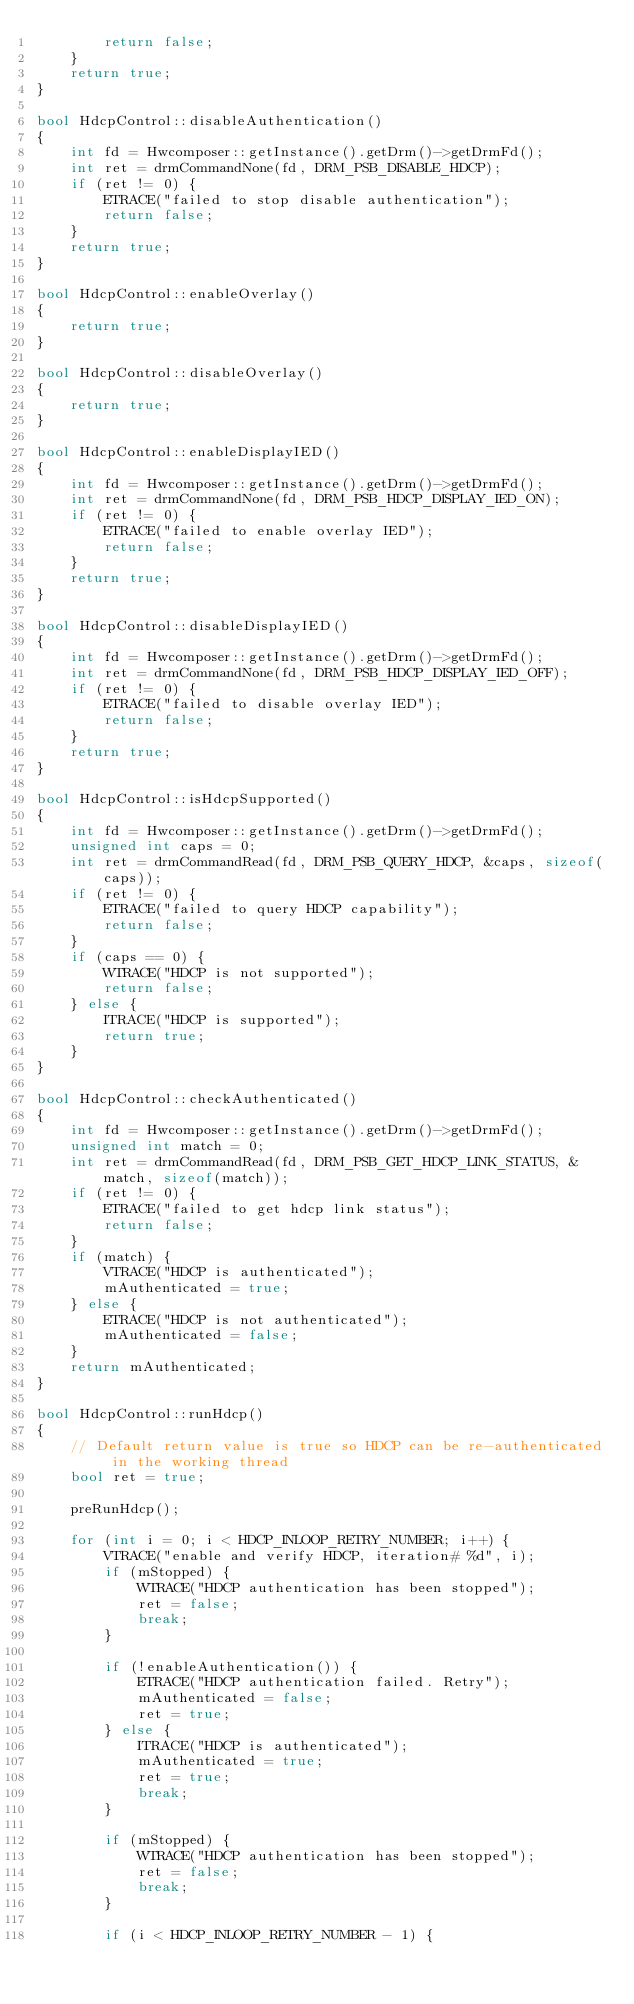Convert code to text. <code><loc_0><loc_0><loc_500><loc_500><_C++_>        return false;
    }
    return true;
}

bool HdcpControl::disableAuthentication()
{
    int fd = Hwcomposer::getInstance().getDrm()->getDrmFd();
    int ret = drmCommandNone(fd, DRM_PSB_DISABLE_HDCP);
    if (ret != 0) {
        ETRACE("failed to stop disable authentication");
        return false;
    }
    return true;
}

bool HdcpControl::enableOverlay()
{
    return true;
}

bool HdcpControl::disableOverlay()
{
    return true;
}

bool HdcpControl::enableDisplayIED()
{
    int fd = Hwcomposer::getInstance().getDrm()->getDrmFd();
    int ret = drmCommandNone(fd, DRM_PSB_HDCP_DISPLAY_IED_ON);
    if (ret != 0) {
        ETRACE("failed to enable overlay IED");
        return false;
    }
    return true;
}

bool HdcpControl::disableDisplayIED()
{
    int fd = Hwcomposer::getInstance().getDrm()->getDrmFd();
    int ret = drmCommandNone(fd, DRM_PSB_HDCP_DISPLAY_IED_OFF);
    if (ret != 0) {
        ETRACE("failed to disable overlay IED");
        return false;
    }
    return true;
}

bool HdcpControl::isHdcpSupported()
{
    int fd = Hwcomposer::getInstance().getDrm()->getDrmFd();
    unsigned int caps = 0;
    int ret = drmCommandRead(fd, DRM_PSB_QUERY_HDCP, &caps, sizeof(caps));
    if (ret != 0) {
        ETRACE("failed to query HDCP capability");
        return false;
    }
    if (caps == 0) {
        WTRACE("HDCP is not supported");
        return false;
    } else {
        ITRACE("HDCP is supported");
        return true;
    }
}

bool HdcpControl::checkAuthenticated()
{
    int fd = Hwcomposer::getInstance().getDrm()->getDrmFd();
    unsigned int match = 0;
    int ret = drmCommandRead(fd, DRM_PSB_GET_HDCP_LINK_STATUS, &match, sizeof(match));
    if (ret != 0) {
        ETRACE("failed to get hdcp link status");
        return false;
    }
    if (match) {
        VTRACE("HDCP is authenticated");
        mAuthenticated = true;
    } else {
        ETRACE("HDCP is not authenticated");
        mAuthenticated = false;
    }
    return mAuthenticated;
}

bool HdcpControl::runHdcp()
{
    // Default return value is true so HDCP can be re-authenticated in the working thread
    bool ret = true;

    preRunHdcp();

    for (int i = 0; i < HDCP_INLOOP_RETRY_NUMBER; i++) {
        VTRACE("enable and verify HDCP, iteration# %d", i);
        if (mStopped) {
            WTRACE("HDCP authentication has been stopped");
            ret = false;
            break;
        }

        if (!enableAuthentication()) {
            ETRACE("HDCP authentication failed. Retry");
            mAuthenticated = false;
            ret = true;
        } else {
            ITRACE("HDCP is authenticated");
            mAuthenticated = true;
            ret = true;
            break;
        }

        if (mStopped) {
            WTRACE("HDCP authentication has been stopped");
            ret = false;
            break;
        }

        if (i < HDCP_INLOOP_RETRY_NUMBER - 1) {</code> 